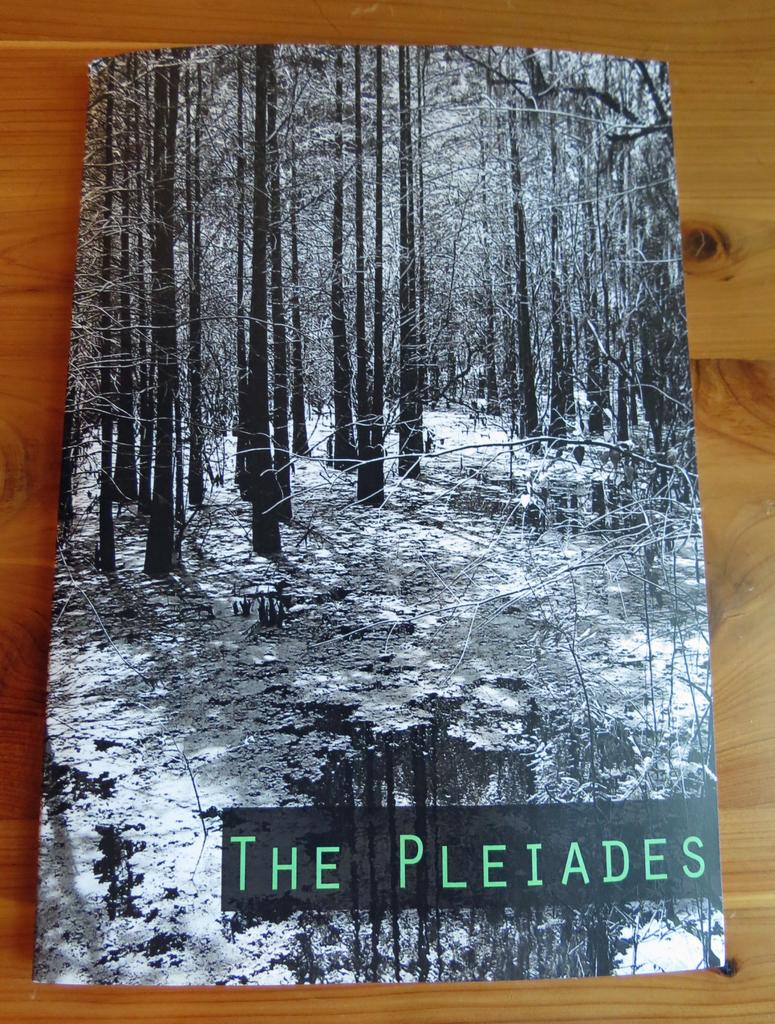What is on the wooden table in the image? There is a book on the wooden table in the image. What type of content does the book contain? The book contains pictures and text. Can you describe the pictures in the book? There are pictures of trees in the book. What time of day is it in the image, and what type of brass object can be seen? The time of day is not mentioned in the image, and there is no brass object present. 